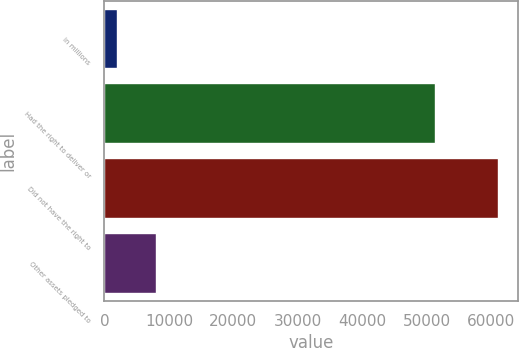Convert chart. <chart><loc_0><loc_0><loc_500><loc_500><bar_chart><fcel>in millions<fcel>Had the right to deliver or<fcel>Did not have the right to<fcel>Other assets pledged to<nl><fcel>2016<fcel>51278<fcel>61099<fcel>7924.3<nl></chart> 